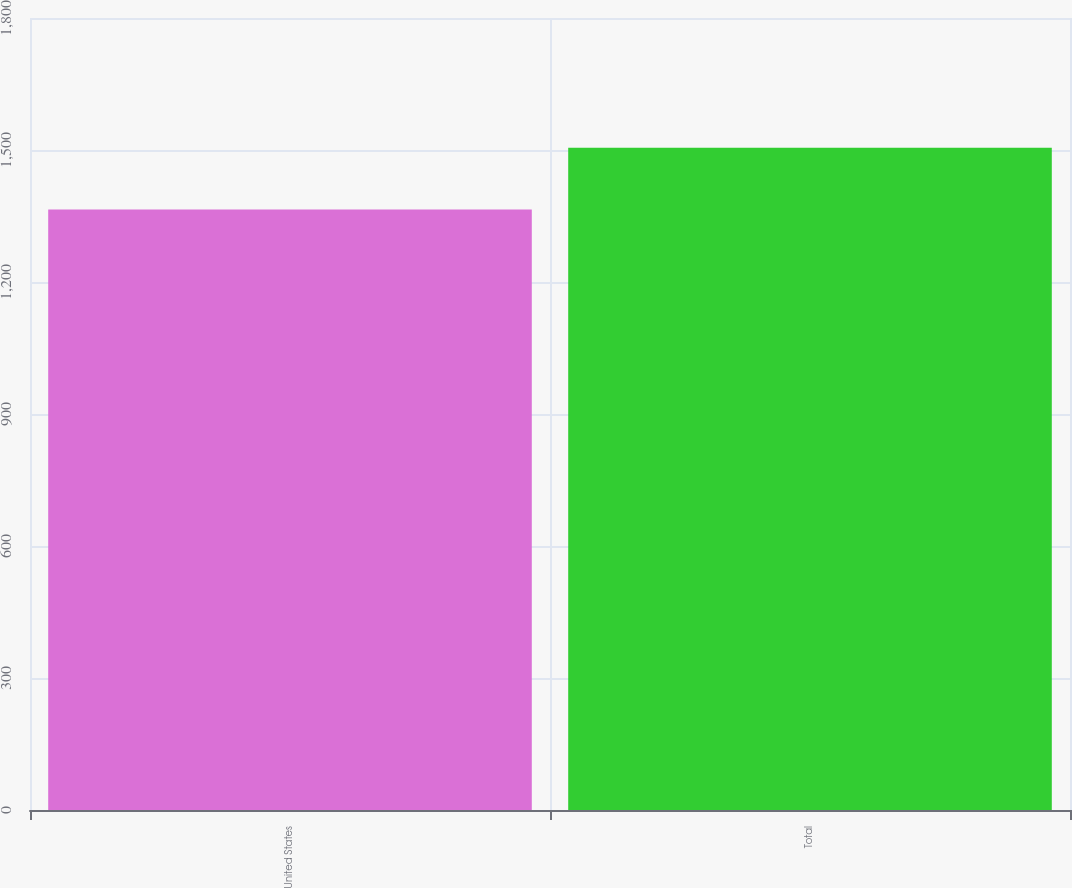Convert chart to OTSL. <chart><loc_0><loc_0><loc_500><loc_500><bar_chart><fcel>United States<fcel>Total<nl><fcel>1365<fcel>1505<nl></chart> 